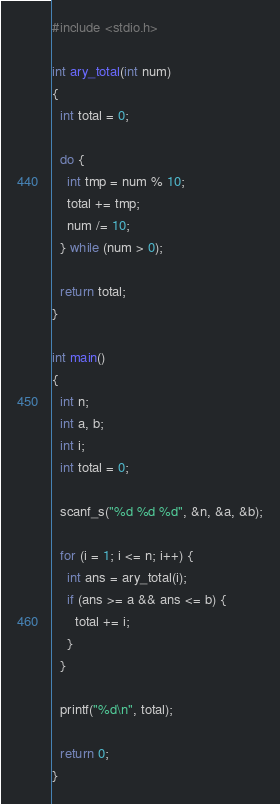<code> <loc_0><loc_0><loc_500><loc_500><_C_>#include <stdio.h>

int ary_total(int num)
{
  int total = 0;
  
  do {
    int tmp = num % 10;
    total += tmp;
    num /= 10;
  } while (num > 0);

  return total;
}

int main()
{
  int n;
  int a, b;
  int i;
  int total = 0;

  scanf_s("%d %d %d", &n, &a, &b);

  for (i = 1; i <= n; i++) {
    int ans = ary_total(i);
    if (ans >= a && ans <= b) {
      total += i;
    }
  }

  printf("%d\n", total);

  return 0;
}</code> 